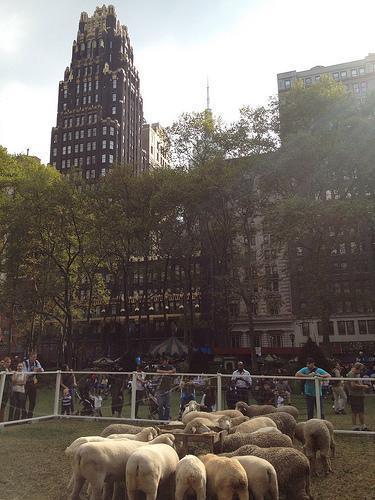How many people have on a blue shirt?
Give a very brief answer. 1. 